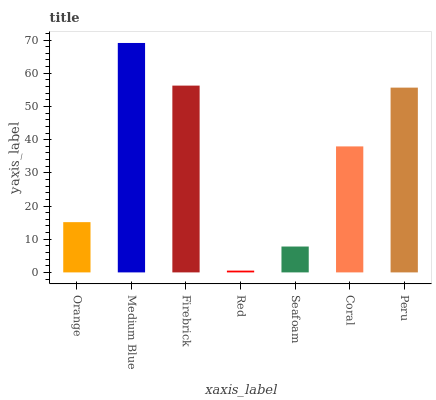Is Firebrick the minimum?
Answer yes or no. No. Is Firebrick the maximum?
Answer yes or no. No. Is Medium Blue greater than Firebrick?
Answer yes or no. Yes. Is Firebrick less than Medium Blue?
Answer yes or no. Yes. Is Firebrick greater than Medium Blue?
Answer yes or no. No. Is Medium Blue less than Firebrick?
Answer yes or no. No. Is Coral the high median?
Answer yes or no. Yes. Is Coral the low median?
Answer yes or no. Yes. Is Seafoam the high median?
Answer yes or no. No. Is Red the low median?
Answer yes or no. No. 